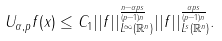<formula> <loc_0><loc_0><loc_500><loc_500>U _ { \alpha , p } f ( x ) \leq C _ { 1 } | | f | | _ { L ^ { \infty } ( \mathbb { R } ^ { n } ) } ^ { \frac { n - \alpha p s } { ( p - 1 ) n } } | | f | | _ { L ^ { s } ( \mathbb { R } ^ { n } ) } ^ { \frac { \alpha p s } { ( p - 1 ) n } } .</formula> 